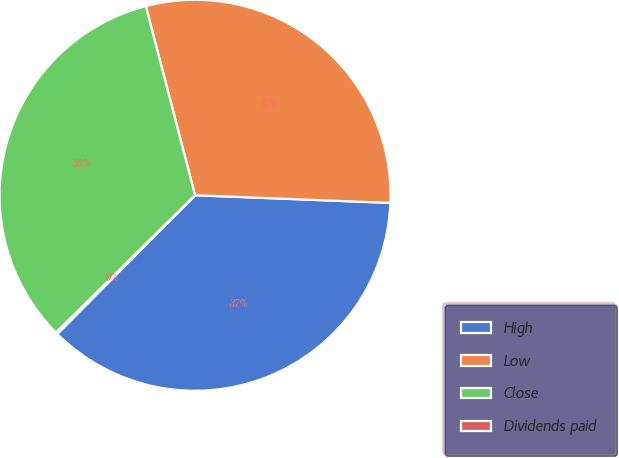Convert chart to OTSL. <chart><loc_0><loc_0><loc_500><loc_500><pie_chart><fcel>High<fcel>Low<fcel>Close<fcel>Dividends paid<nl><fcel>36.82%<fcel>29.67%<fcel>33.35%<fcel>0.15%<nl></chart> 